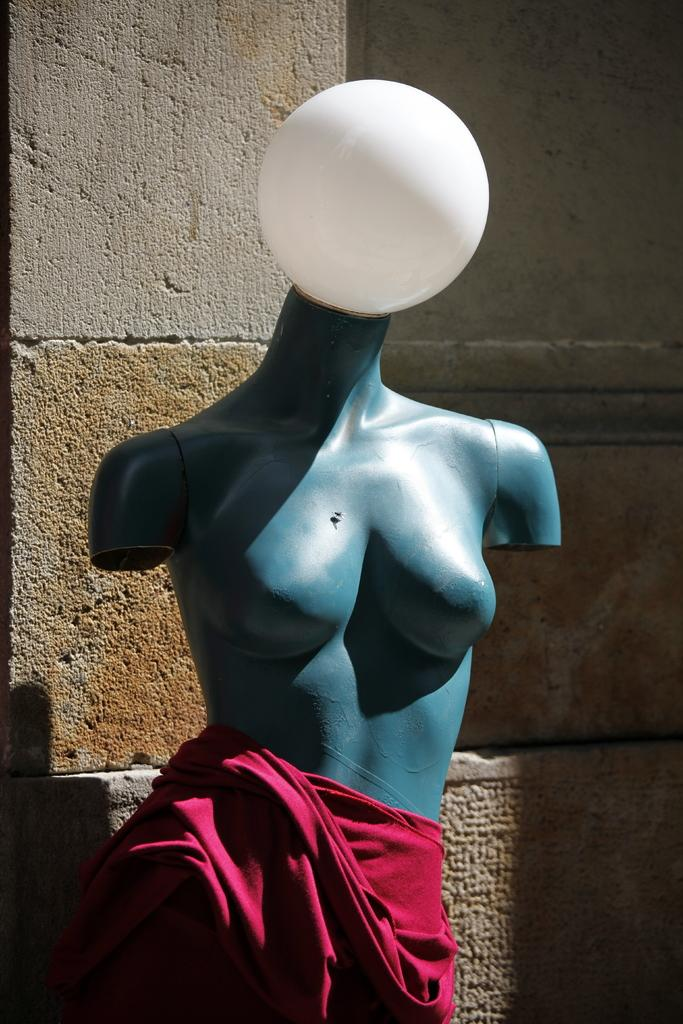What is the main subject of the image? There is a statue of a woman in the image. What is the woman wearing in the image? The woman is partially nude and wearing a red color dress. What can be seen in the background of the image? There is a wall in the image. What type of glue is being used to attach the woman's dress to the statue in the image? There is no glue present in the image, and the woman's dress is not being attached to the statue. 